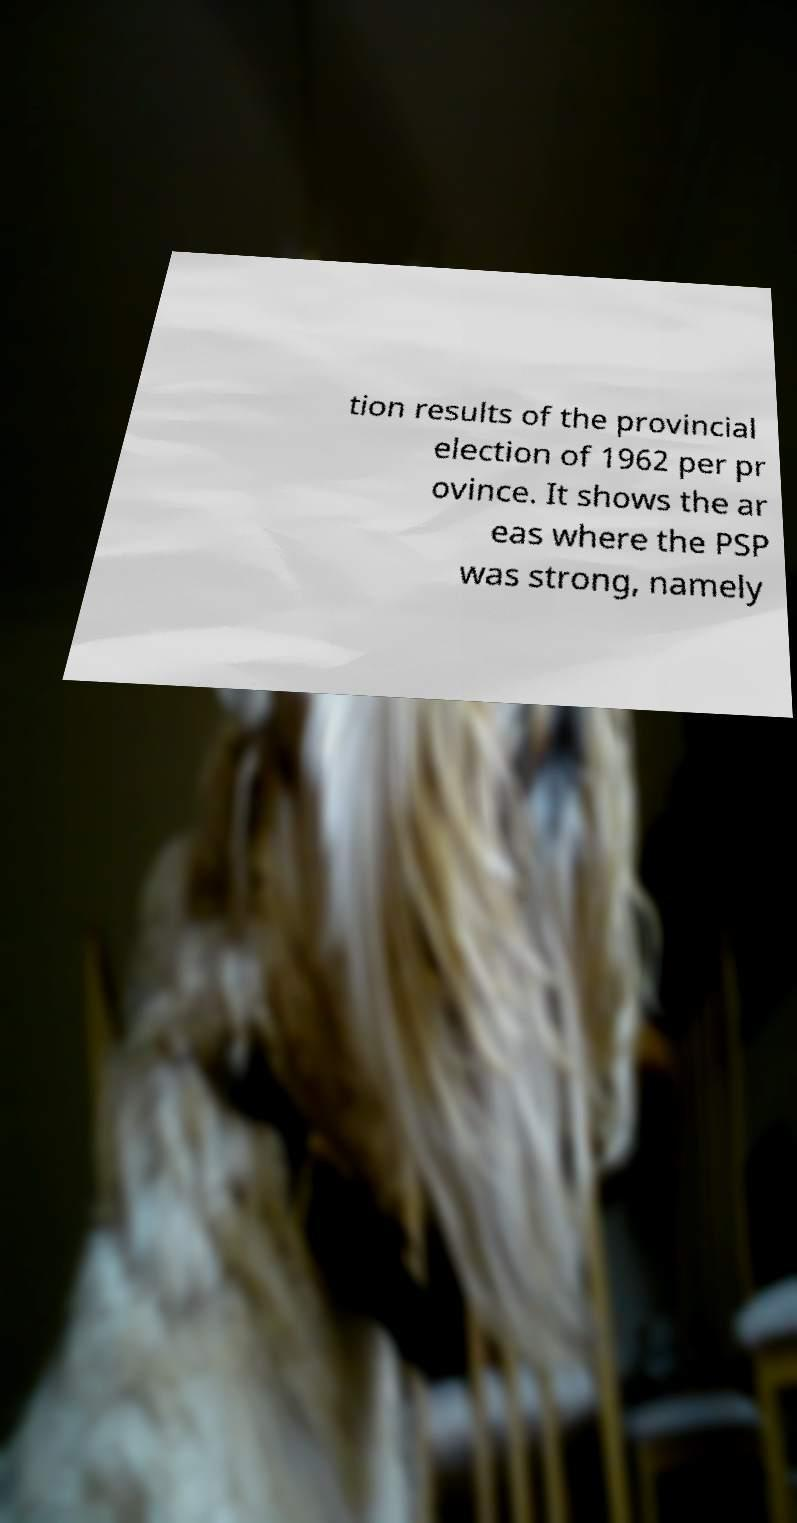Can you accurately transcribe the text from the provided image for me? tion results of the provincial election of 1962 per pr ovince. It shows the ar eas where the PSP was strong, namely 